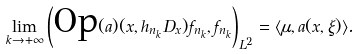<formula> <loc_0><loc_0><loc_500><loc_500>\lim _ { k \rightarrow + \infty } \left ( \text {Op} ( a ) ( x , h _ { n _ { k } } D _ { x } ) f _ { n _ { k } } , f _ { n _ { k } } \right ) _ { L ^ { 2 } } = \langle \mu , a ( x , \xi ) \rangle .</formula> 